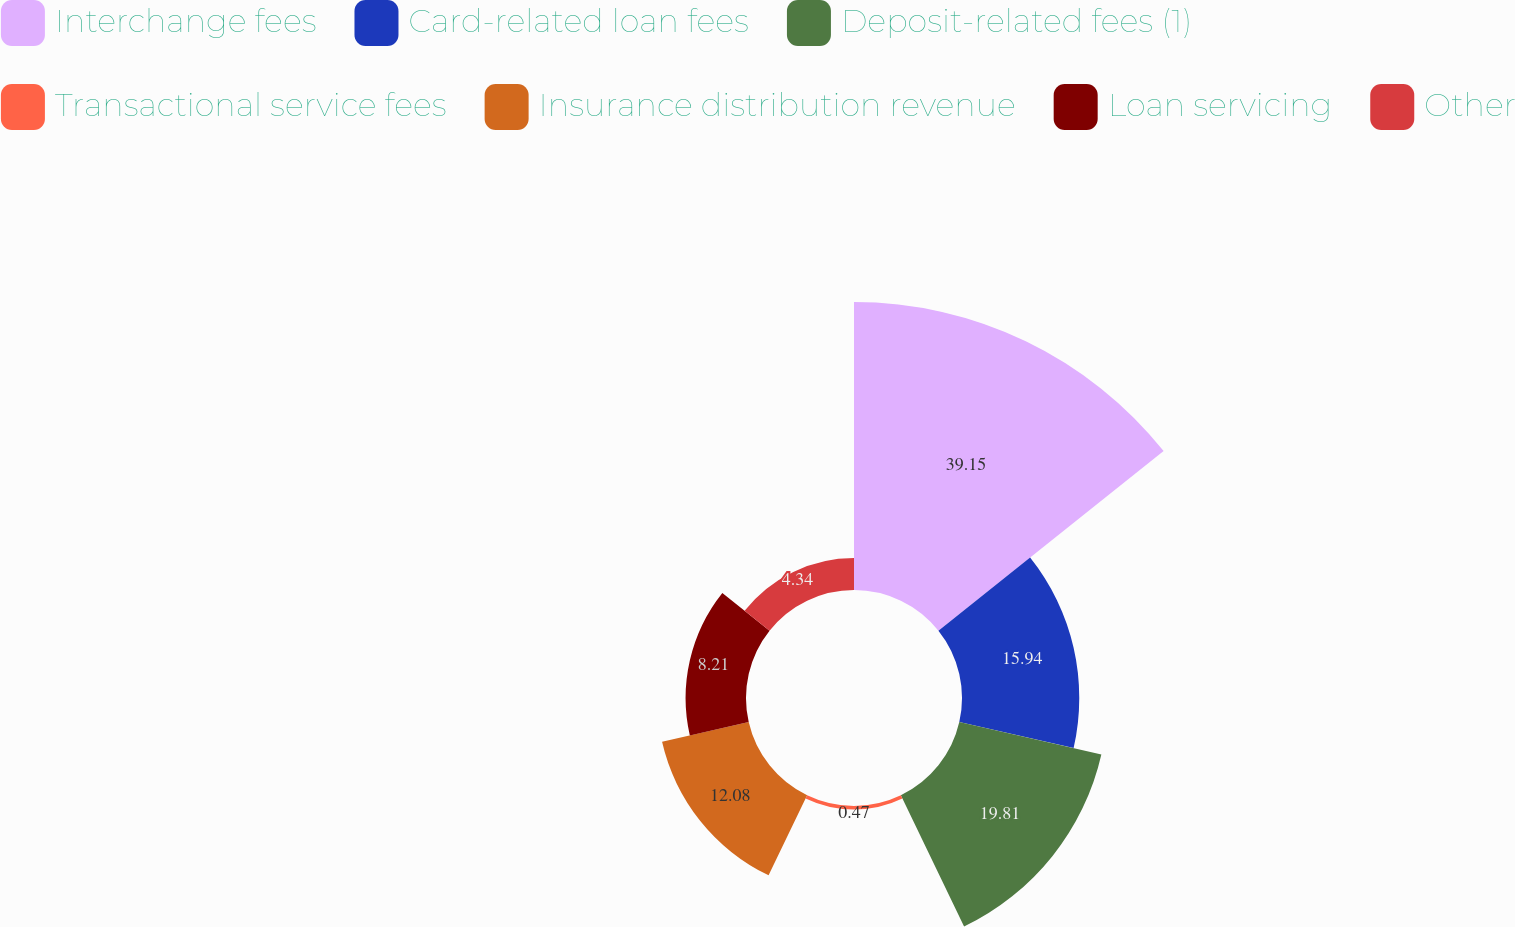Convert chart. <chart><loc_0><loc_0><loc_500><loc_500><pie_chart><fcel>Interchange fees<fcel>Card-related loan fees<fcel>Deposit-related fees (1)<fcel>Transactional service fees<fcel>Insurance distribution revenue<fcel>Loan servicing<fcel>Other<nl><fcel>39.15%<fcel>15.94%<fcel>19.81%<fcel>0.47%<fcel>12.08%<fcel>8.21%<fcel>4.34%<nl></chart> 